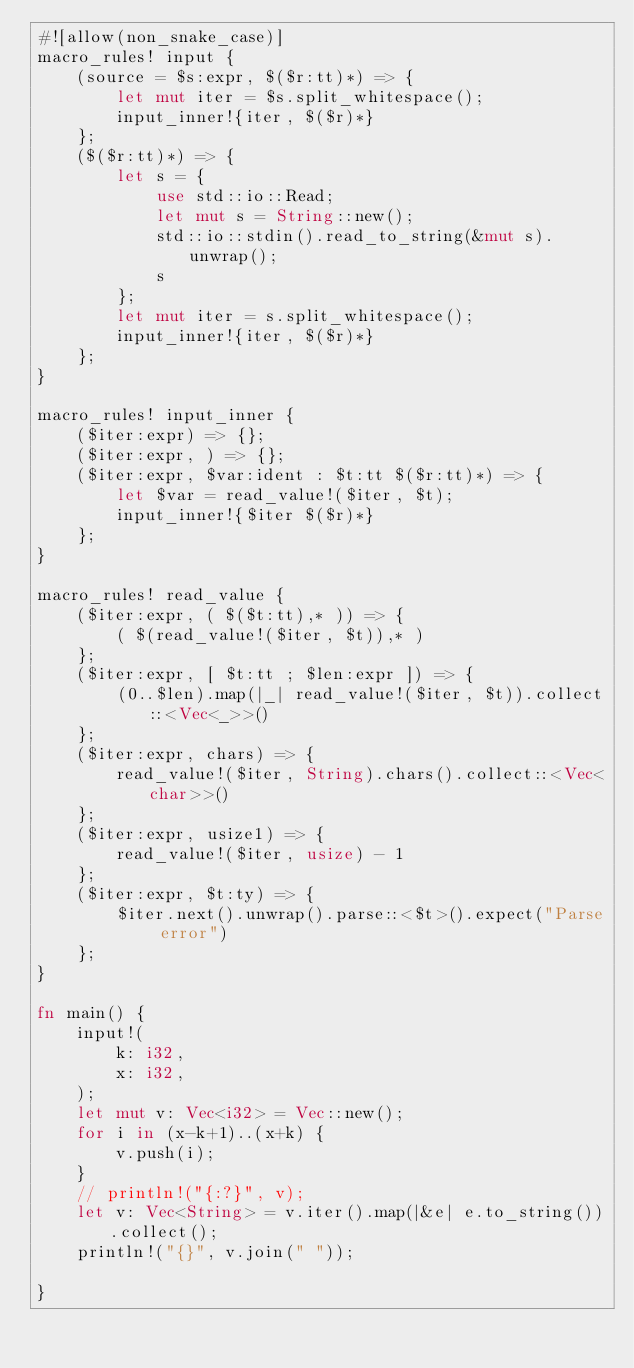Convert code to text. <code><loc_0><loc_0><loc_500><loc_500><_Rust_>#![allow(non_snake_case)]
macro_rules! input {
    (source = $s:expr, $($r:tt)*) => {
        let mut iter = $s.split_whitespace();
        input_inner!{iter, $($r)*}
    };
    ($($r:tt)*) => {
        let s = {
            use std::io::Read;
            let mut s = String::new();
            std::io::stdin().read_to_string(&mut s).unwrap();
            s
        };
        let mut iter = s.split_whitespace();
        input_inner!{iter, $($r)*}
    };
}

macro_rules! input_inner {
    ($iter:expr) => {};
    ($iter:expr, ) => {};
    ($iter:expr, $var:ident : $t:tt $($r:tt)*) => {
        let $var = read_value!($iter, $t);
        input_inner!{$iter $($r)*}
    };
}

macro_rules! read_value {
    ($iter:expr, ( $($t:tt),* )) => {
        ( $(read_value!($iter, $t)),* )
    };
    ($iter:expr, [ $t:tt ; $len:expr ]) => {
        (0..$len).map(|_| read_value!($iter, $t)).collect::<Vec<_>>()
    };
    ($iter:expr, chars) => {
        read_value!($iter, String).chars().collect::<Vec<char>>()
    };
    ($iter:expr, usize1) => {
        read_value!($iter, usize) - 1
    };
    ($iter:expr, $t:ty) => {
        $iter.next().unwrap().parse::<$t>().expect("Parse error")
    };
}

fn main() {
    input!(
        k: i32,
        x: i32,
    );
    let mut v: Vec<i32> = Vec::new();
    for i in (x-k+1)..(x+k) {
        v.push(i);
    }
    // println!("{:?}", v);
    let v: Vec<String> = v.iter().map(|&e| e.to_string()).collect();
    println!("{}", v.join(" "));

}
</code> 